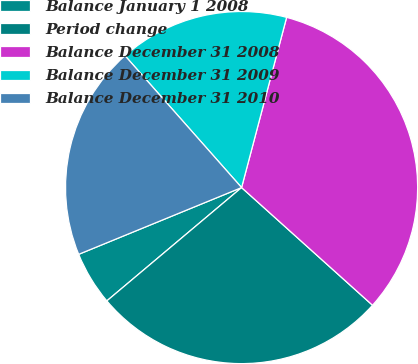Convert chart. <chart><loc_0><loc_0><loc_500><loc_500><pie_chart><fcel>Balance January 1 2008<fcel>Period change<fcel>Balance December 31 2008<fcel>Balance December 31 2009<fcel>Balance December 31 2010<nl><fcel>4.94%<fcel>27.22%<fcel>32.54%<fcel>15.64%<fcel>19.67%<nl></chart> 